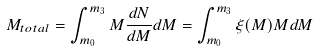Convert formula to latex. <formula><loc_0><loc_0><loc_500><loc_500>M _ { t o t a l } = \int _ { m _ { 0 } } ^ { m _ { 3 } } M \frac { d N } { d M } d M = \int _ { m _ { 0 } } ^ { m _ { 3 } } \xi ( M ) M d M</formula> 